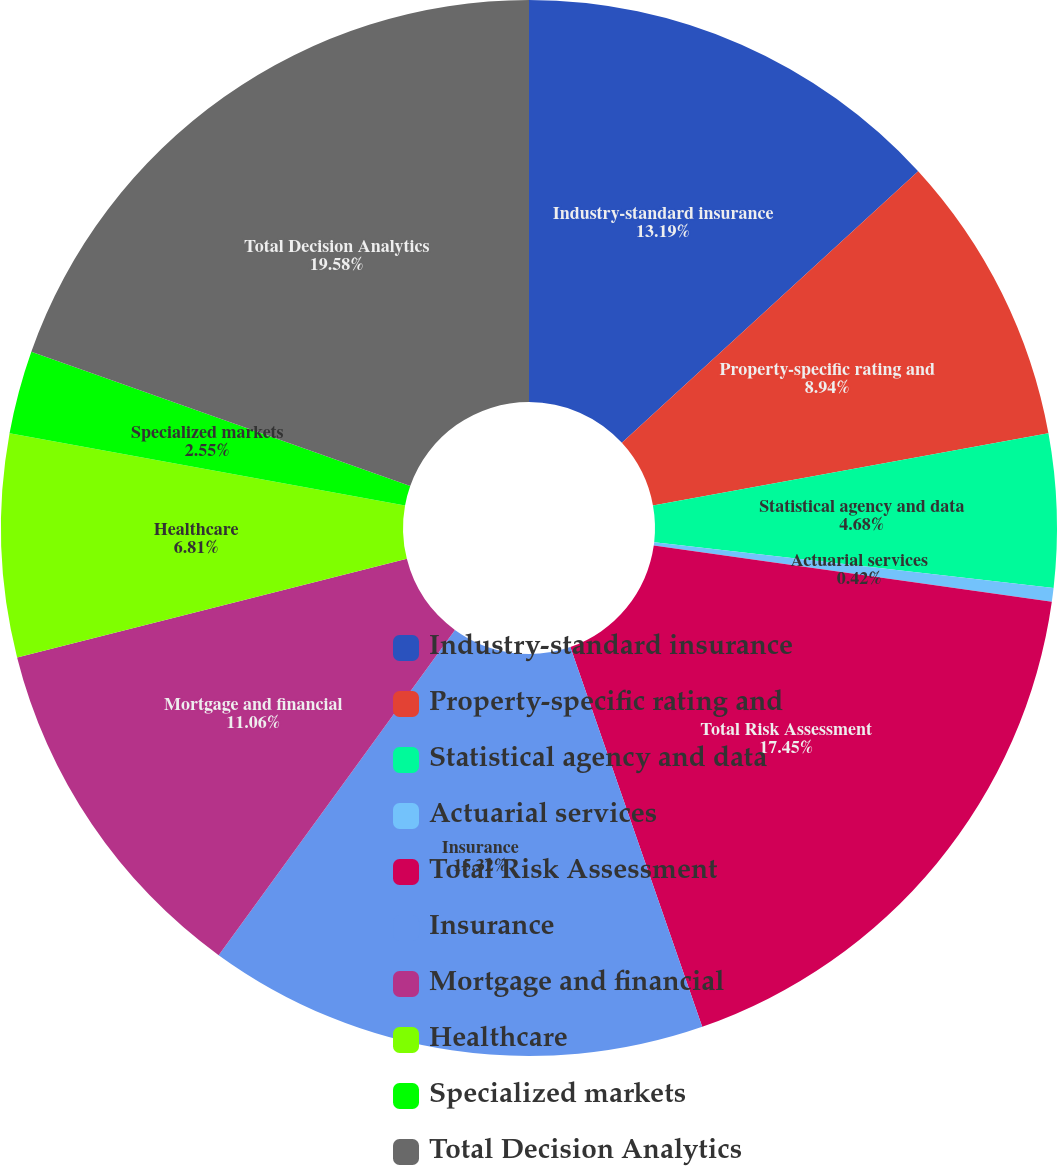Convert chart. <chart><loc_0><loc_0><loc_500><loc_500><pie_chart><fcel>Industry-standard insurance<fcel>Property-specific rating and<fcel>Statistical agency and data<fcel>Actuarial services<fcel>Total Risk Assessment<fcel>Insurance<fcel>Mortgage and financial<fcel>Healthcare<fcel>Specialized markets<fcel>Total Decision Analytics<nl><fcel>13.19%<fcel>8.94%<fcel>4.68%<fcel>0.42%<fcel>17.45%<fcel>15.32%<fcel>11.06%<fcel>6.81%<fcel>2.55%<fcel>19.58%<nl></chart> 